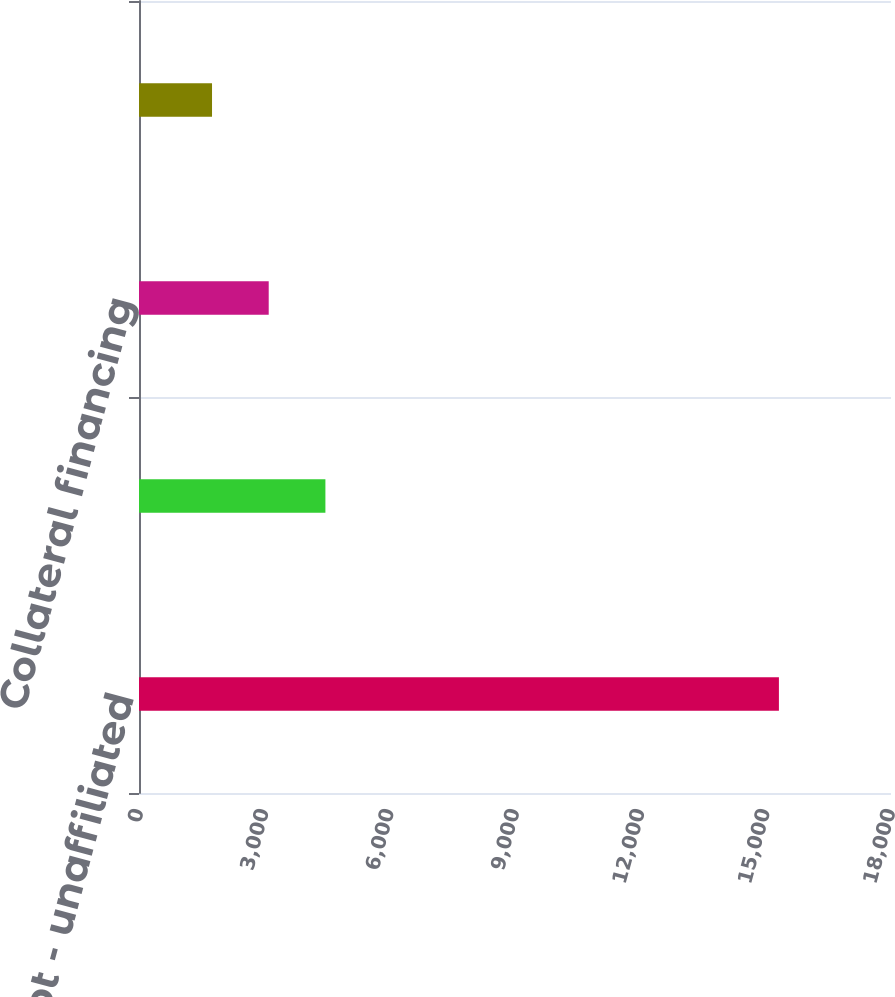Convert chart to OTSL. <chart><loc_0><loc_0><loc_500><loc_500><bar_chart><fcel>Long-term debt - unaffiliated<fcel>Long-term debt - affiliated<fcel>Collateral financing<fcel>Junior subordinated debt<nl><fcel>15317<fcel>4461.8<fcel>3104.9<fcel>1748<nl></chart> 